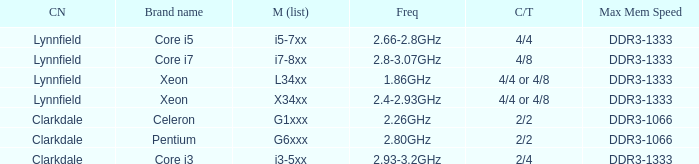What frequency does the Pentium processor use? 2.80GHz. Could you help me parse every detail presented in this table? {'header': ['CN', 'Brand name', 'M (list)', 'Freq', 'C/T', 'Max Mem Speed'], 'rows': [['Lynnfield', 'Core i5', 'i5-7xx', '2.66-2.8GHz', '4/4', 'DDR3-1333'], ['Lynnfield', 'Core i7', 'i7-8xx', '2.8-3.07GHz', '4/8', 'DDR3-1333'], ['Lynnfield', 'Xeon', 'L34xx', '1.86GHz', '4/4 or 4/8', 'DDR3-1333'], ['Lynnfield', 'Xeon', 'X34xx', '2.4-2.93GHz', '4/4 or 4/8', 'DDR3-1333'], ['Clarkdale', 'Celeron', 'G1xxx', '2.26GHz', '2/2', 'DDR3-1066'], ['Clarkdale', 'Pentium', 'G6xxx', '2.80GHz', '2/2', 'DDR3-1066'], ['Clarkdale', 'Core i3', 'i3-5xx', '2.93-3.2GHz', '2/4', 'DDR3-1333']]} 